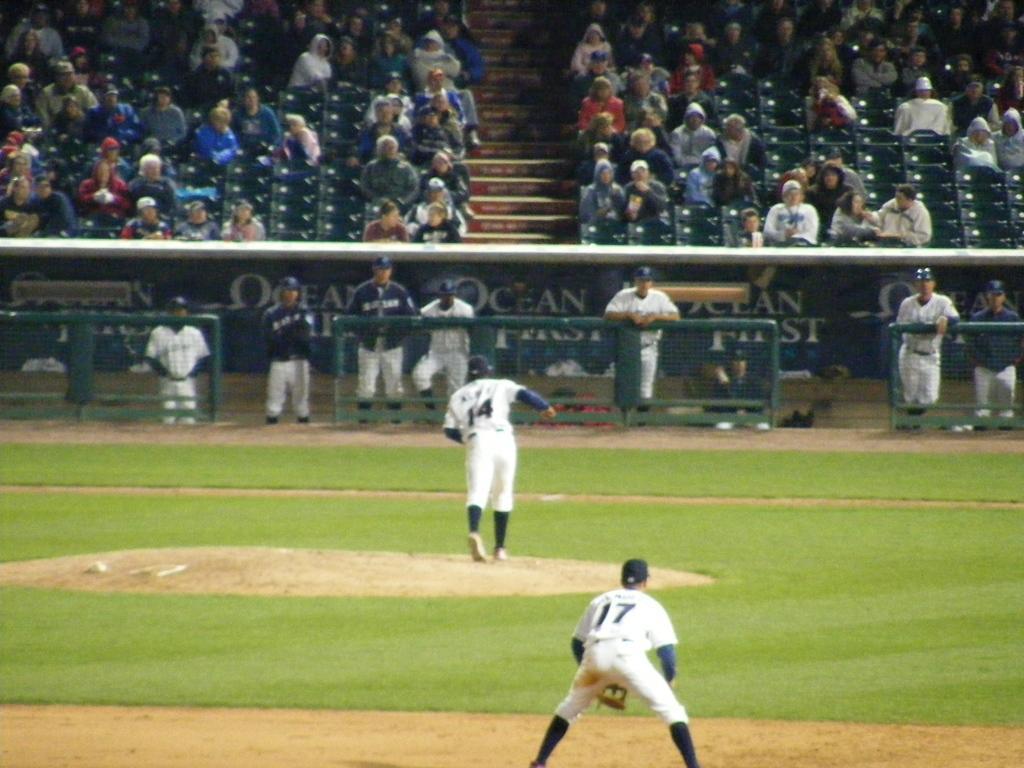Describe this image in one or two sentences. In this image I can see a ground and there are two persons in the ground and at the top of the picture I can see some spectators. There are some grills separating spectators from the players. 